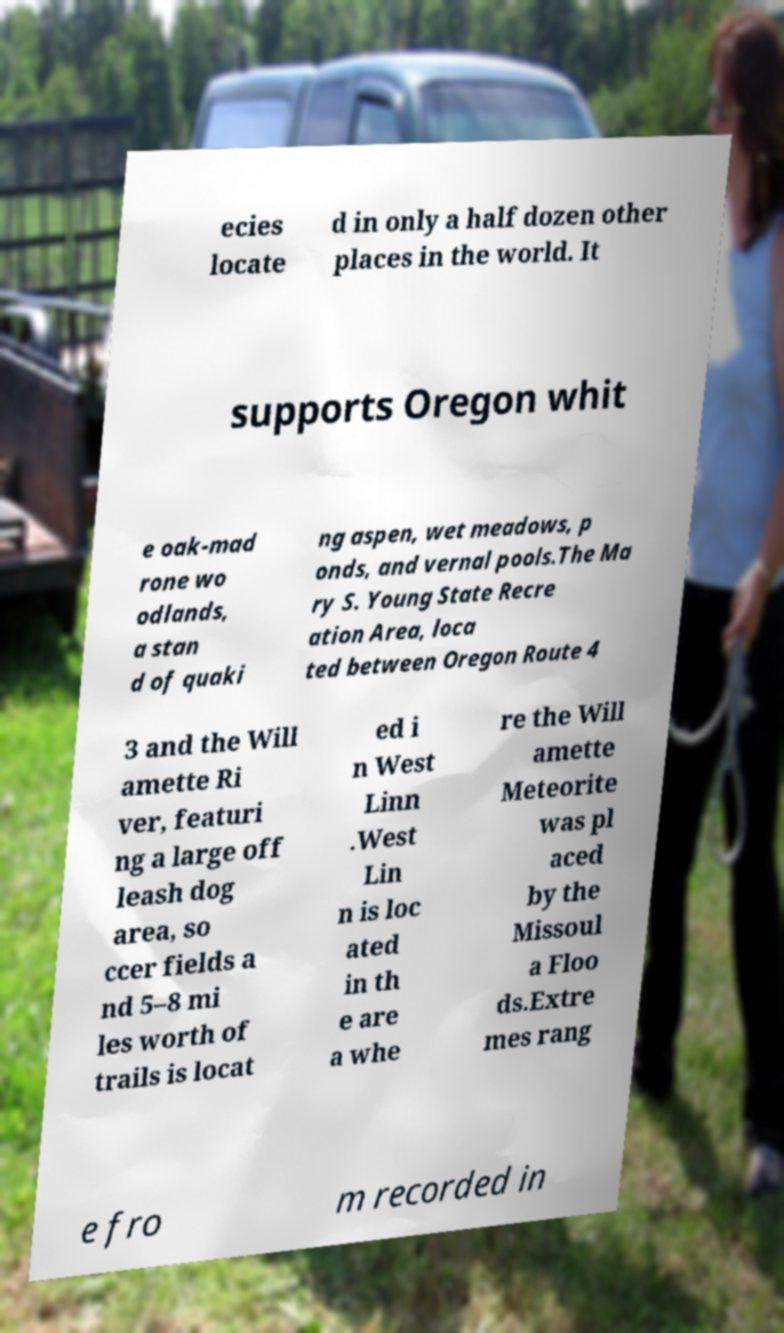I need the written content from this picture converted into text. Can you do that? ecies locate d in only a half dozen other places in the world. It supports Oregon whit e oak-mad rone wo odlands, a stan d of quaki ng aspen, wet meadows, p onds, and vernal pools.The Ma ry S. Young State Recre ation Area, loca ted between Oregon Route 4 3 and the Will amette Ri ver, featuri ng a large off leash dog area, so ccer fields a nd 5–8 mi les worth of trails is locat ed i n West Linn .West Lin n is loc ated in th e are a whe re the Will amette Meteorite was pl aced by the Missoul a Floo ds.Extre mes rang e fro m recorded in 